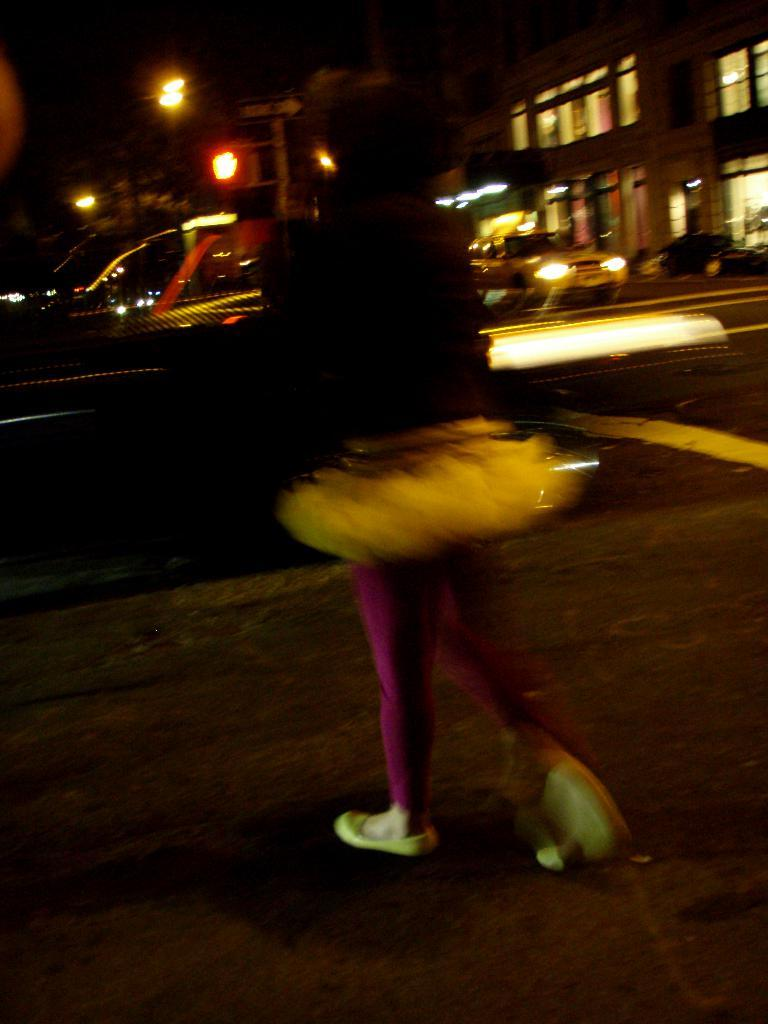What type of structures can be seen in the image? There are buildings in the image. What can be seen illuminated in the image? There are lights visible in the image. What architectural features are present in the buildings? There are windows in the image. What type of transportation is present in the image? There are vehicles in the image. Can you describe the person in the image? There is a person standing in the image. How would you describe the overall lighting in the image? The image is dark. What shape is the basin in the image? There is no basin present in the image. --- Facts: 1. There is a person in the image. 2. The person is wearing a hat. 3. The person is holding a book. 4. The person is standing in front of a bookshelf. 5. The bookshelf is filled with books. Absurd Topics: elephant, piano, parrot Conversation: What is the main subject in the image? There is a person in the image. What is the person wearing in the image? The person is wearing a hat. What is the person holding in the image? The person is holding a book. What is the person standing in front of in the image? The person is standing in front of a bookshelf. What can be observed about the bookshelf in the image? The bookshelf is filled with books. Reasoning: Let's think step by step in order to produce the conversation. We start by identifying the main subject of the image, which is the person. Next, we describe specific features of the person, such as the hat and the book they are holding. Then, we observe the person's location in relation to the image, noting that they are standing in front of a bookshelf. Finally, we describe the bookshelf's condition, which is filled with books. Absurd Question/Answer: What type of piano can be seen being played by a parrot in the image? There is no piano or parrot present in the image. 